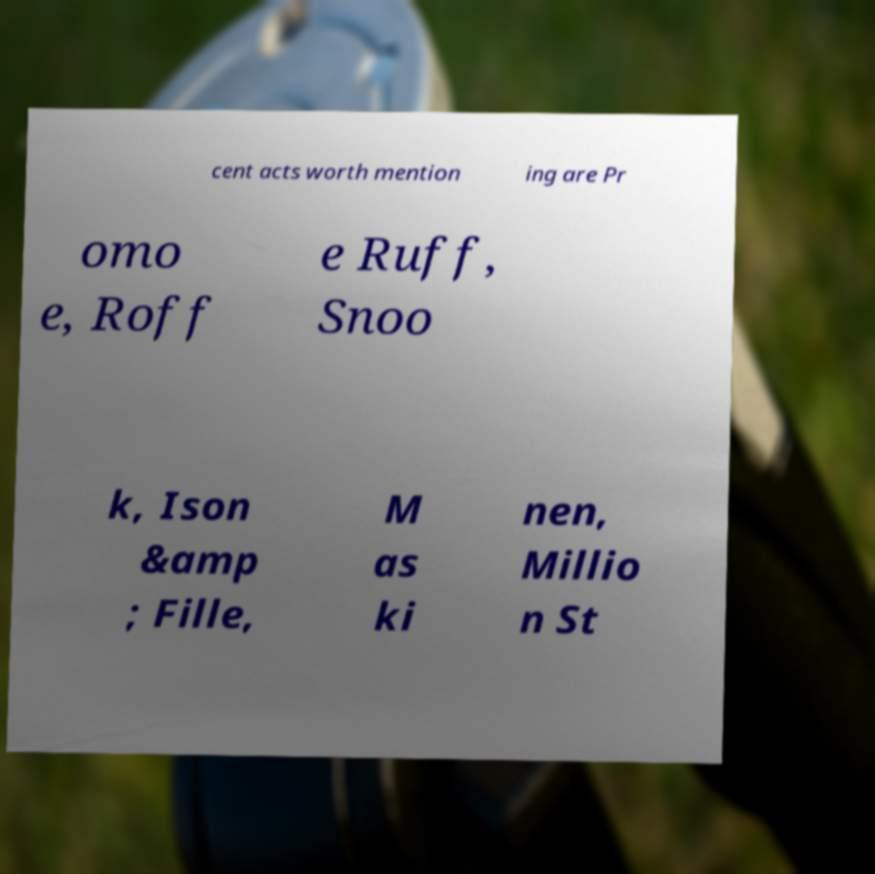Can you read and provide the text displayed in the image?This photo seems to have some interesting text. Can you extract and type it out for me? cent acts worth mention ing are Pr omo e, Roff e Ruff, Snoo k, Ison &amp ; Fille, M as ki nen, Millio n St 